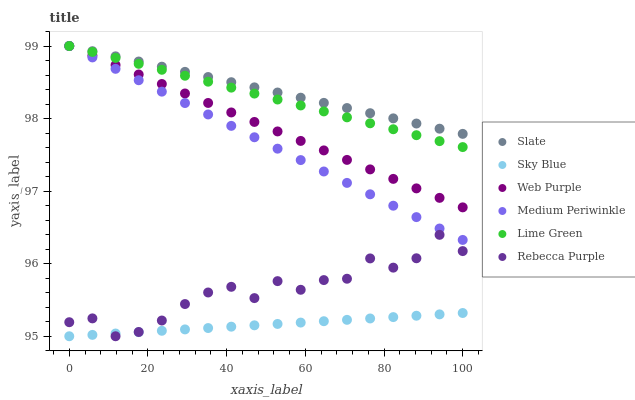Does Sky Blue have the minimum area under the curve?
Answer yes or no. Yes. Does Slate have the maximum area under the curve?
Answer yes or no. Yes. Does Medium Periwinkle have the minimum area under the curve?
Answer yes or no. No. Does Medium Periwinkle have the maximum area under the curve?
Answer yes or no. No. Is Web Purple the smoothest?
Answer yes or no. Yes. Is Rebecca Purple the roughest?
Answer yes or no. Yes. Is Medium Periwinkle the smoothest?
Answer yes or no. No. Is Medium Periwinkle the roughest?
Answer yes or no. No. Does Rebecca Purple have the lowest value?
Answer yes or no. Yes. Does Medium Periwinkle have the lowest value?
Answer yes or no. No. Does Lime Green have the highest value?
Answer yes or no. Yes. Does Rebecca Purple have the highest value?
Answer yes or no. No. Is Sky Blue less than Web Purple?
Answer yes or no. Yes. Is Slate greater than Sky Blue?
Answer yes or no. Yes. Does Sky Blue intersect Rebecca Purple?
Answer yes or no. Yes. Is Sky Blue less than Rebecca Purple?
Answer yes or no. No. Is Sky Blue greater than Rebecca Purple?
Answer yes or no. No. Does Sky Blue intersect Web Purple?
Answer yes or no. No. 